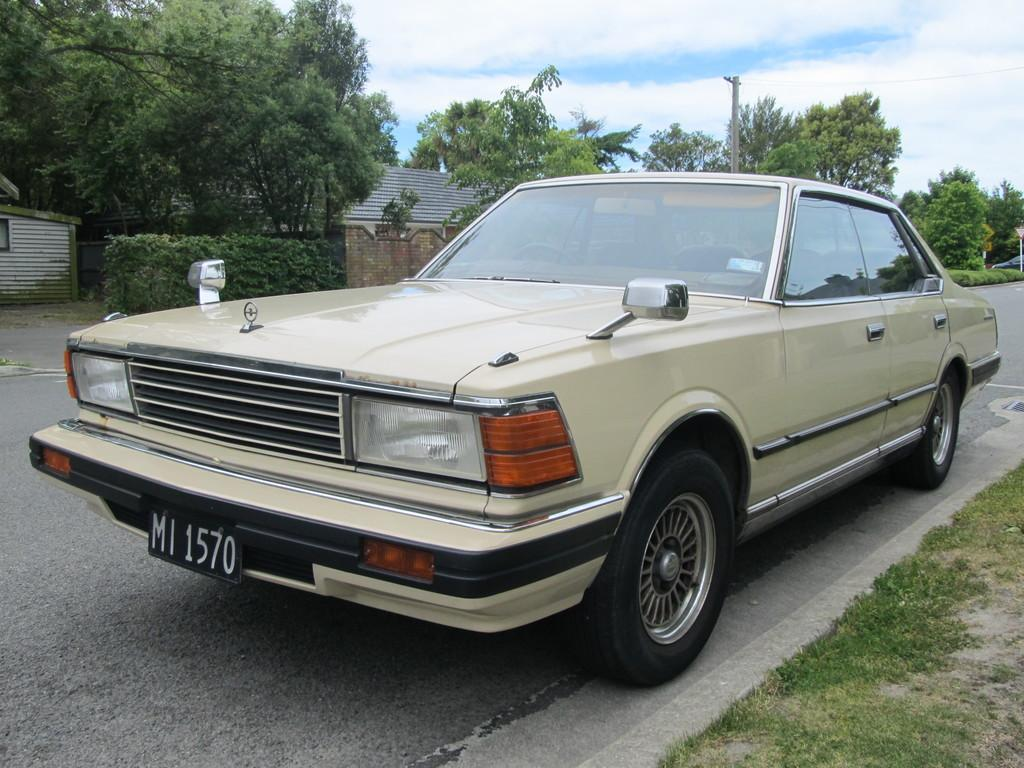What is parked in the image? There is a car parked in the image. Where is the car parked? The car is parked on the side of a road. What can be seen in the background of the image? There are trees, buildings, and the sky visible in the background of the image. What is the car writing on the window in the morning? There is no car writing on a window in the image, and the time of day is not mentioned. 